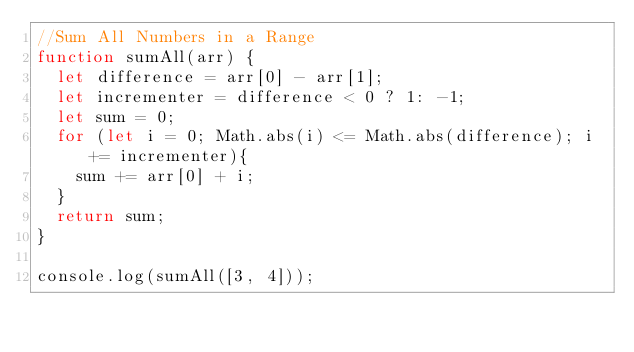Convert code to text. <code><loc_0><loc_0><loc_500><loc_500><_JavaScript_>//Sum All Numbers in a Range
function sumAll(arr) {
  let difference = arr[0] - arr[1];
  let incrementer = difference < 0 ? 1: -1;
  let sum = 0;
  for (let i = 0; Math.abs(i) <= Math.abs(difference); i += incrementer){
    sum += arr[0] + i;
  }
  return sum;
}

console.log(sumAll([3, 4]));</code> 